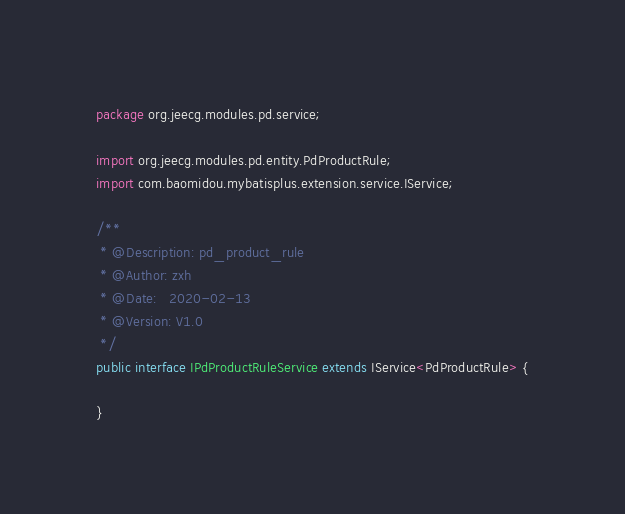<code> <loc_0><loc_0><loc_500><loc_500><_Java_>package org.jeecg.modules.pd.service;

import org.jeecg.modules.pd.entity.PdProductRule;
import com.baomidou.mybatisplus.extension.service.IService;

/**
 * @Description: pd_product_rule
 * @Author: zxh
 * @Date:   2020-02-13
 * @Version: V1.0
 */
public interface IPdProductRuleService extends IService<PdProductRule> {

}
</code> 